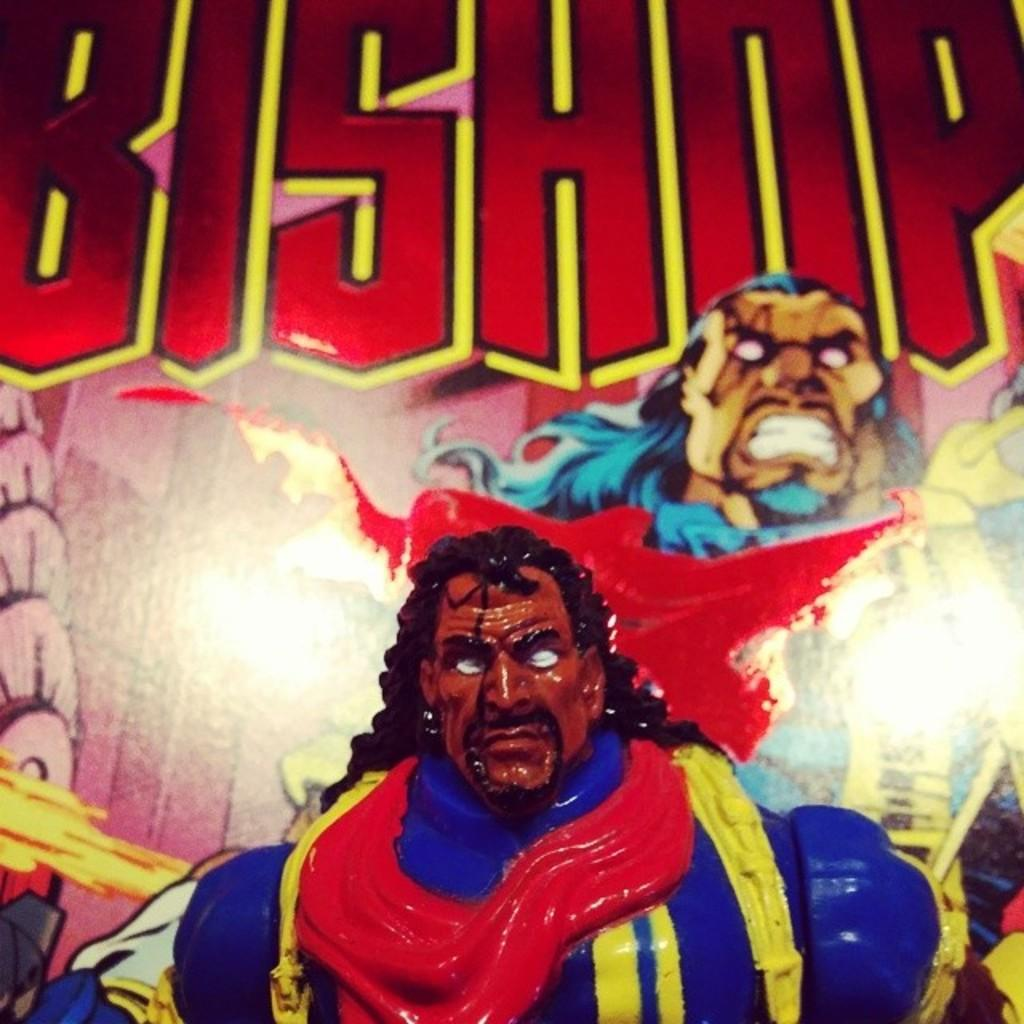What object can be seen in the image? There is a toy in the image. What can be seen in the background of the image? There is a picture of a person and text written on the wall in the background of the image. Can you see a van driving through the ocean in the image? No, there is no van or ocean present in the image. 